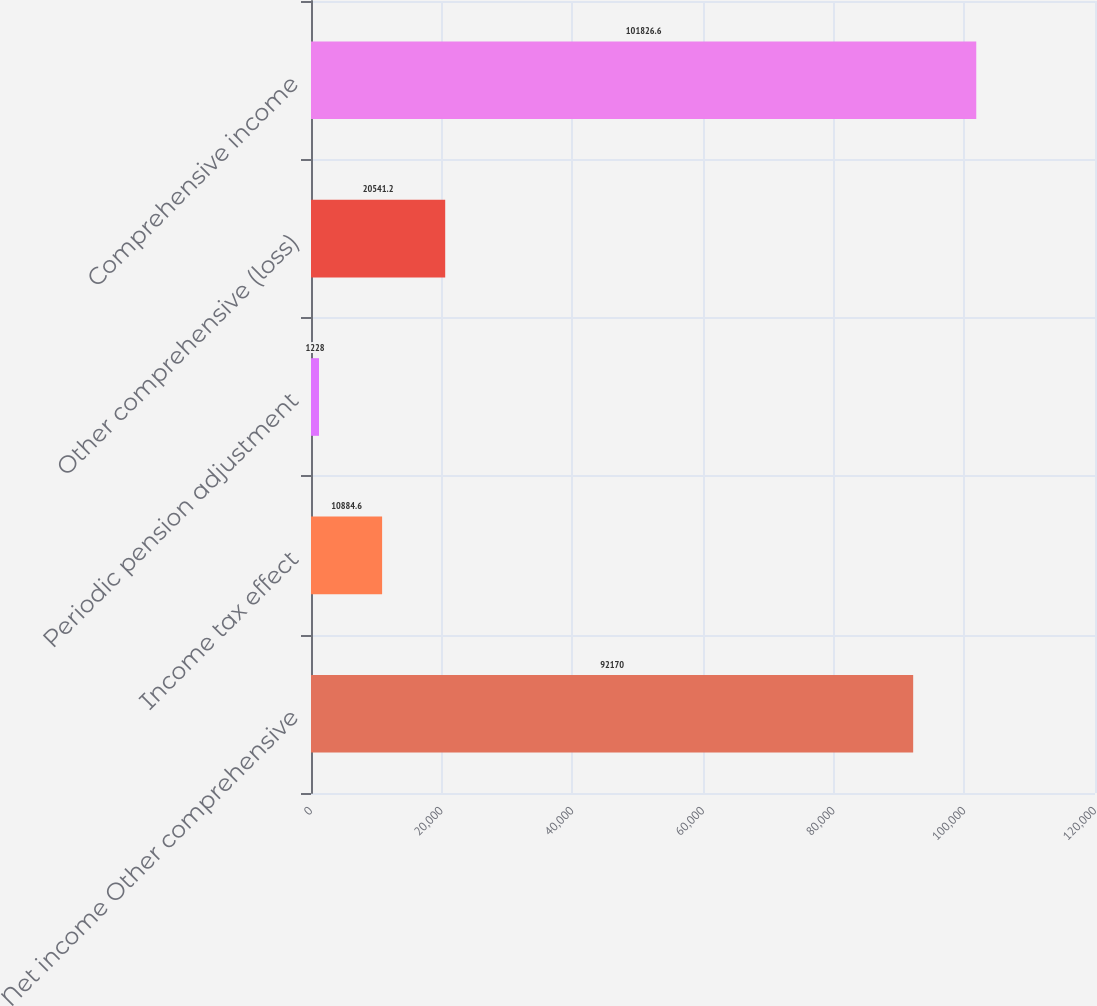Convert chart. <chart><loc_0><loc_0><loc_500><loc_500><bar_chart><fcel>Net income Other comprehensive<fcel>Income tax effect<fcel>Periodic pension adjustment<fcel>Other comprehensive (loss)<fcel>Comprehensive income<nl><fcel>92170<fcel>10884.6<fcel>1228<fcel>20541.2<fcel>101827<nl></chart> 